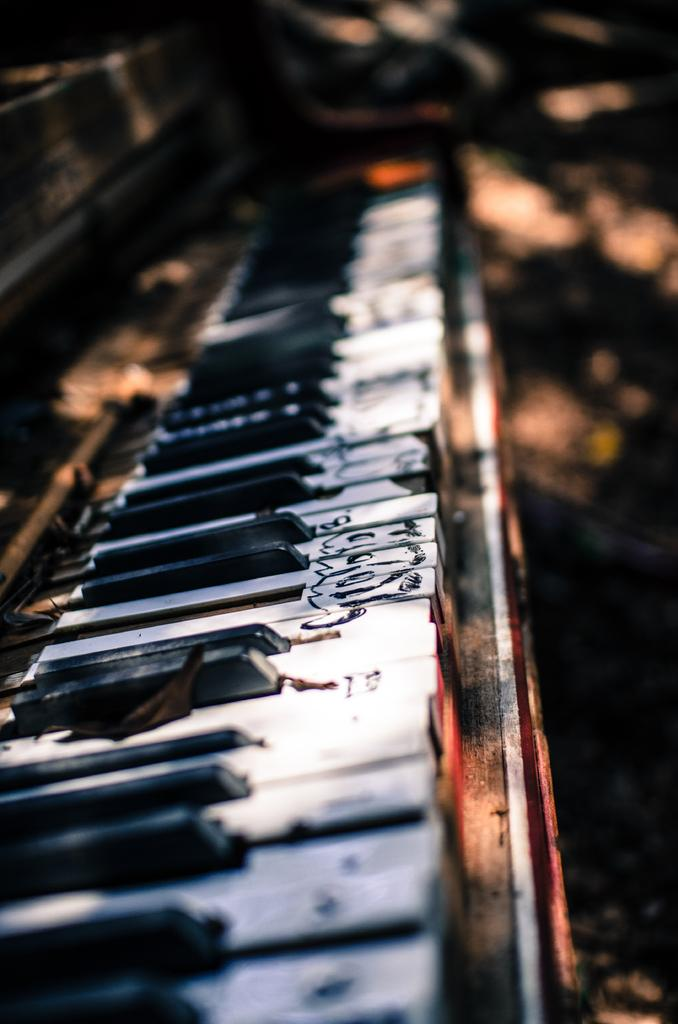What musical instrument can be seen in the image? There is a piano in the image. What type of natural material is present in the image? Dry leaves are present in the image. What type of silver record can be seen on the piano in the image? There is no silver record present on the piano in the image; only a piano and dry leaves are visible. 